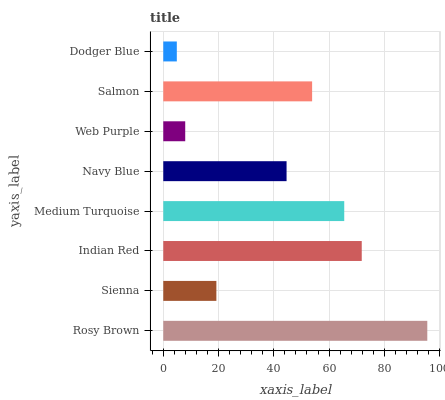Is Dodger Blue the minimum?
Answer yes or no. Yes. Is Rosy Brown the maximum?
Answer yes or no. Yes. Is Sienna the minimum?
Answer yes or no. No. Is Sienna the maximum?
Answer yes or no. No. Is Rosy Brown greater than Sienna?
Answer yes or no. Yes. Is Sienna less than Rosy Brown?
Answer yes or no. Yes. Is Sienna greater than Rosy Brown?
Answer yes or no. No. Is Rosy Brown less than Sienna?
Answer yes or no. No. Is Salmon the high median?
Answer yes or no. Yes. Is Navy Blue the low median?
Answer yes or no. Yes. Is Sienna the high median?
Answer yes or no. No. Is Sienna the low median?
Answer yes or no. No. 